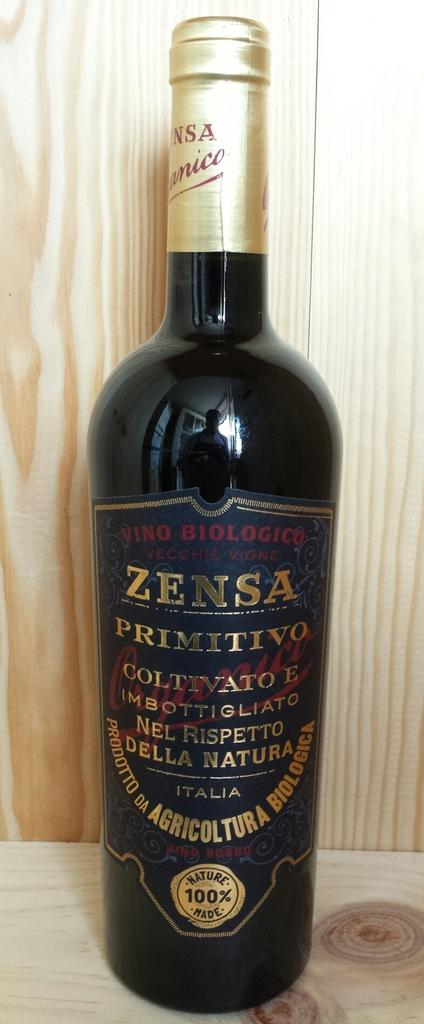<image>
Offer a succinct explanation of the picture presented. A black bottle of Zensa in front of a wooden wall. 